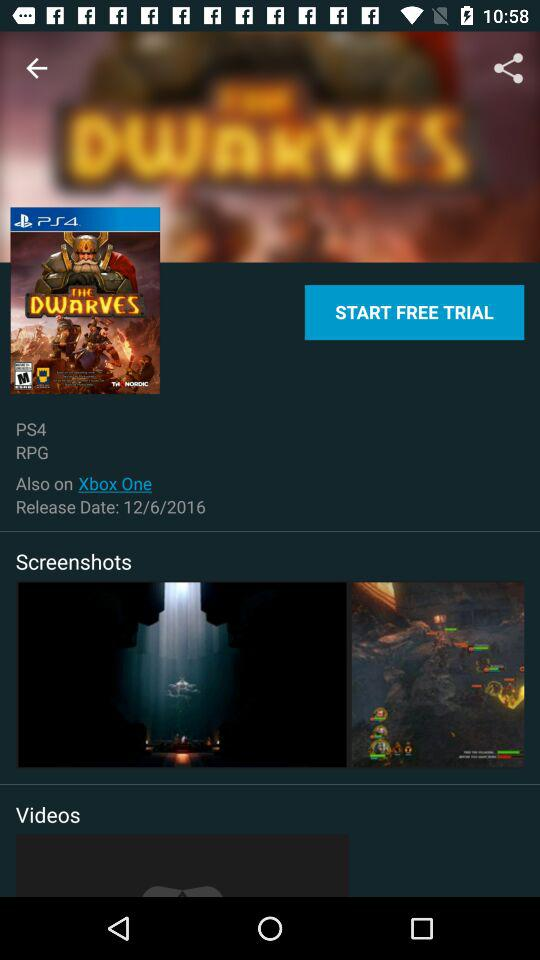What is the given release date? The release date is December 6, 2016. 